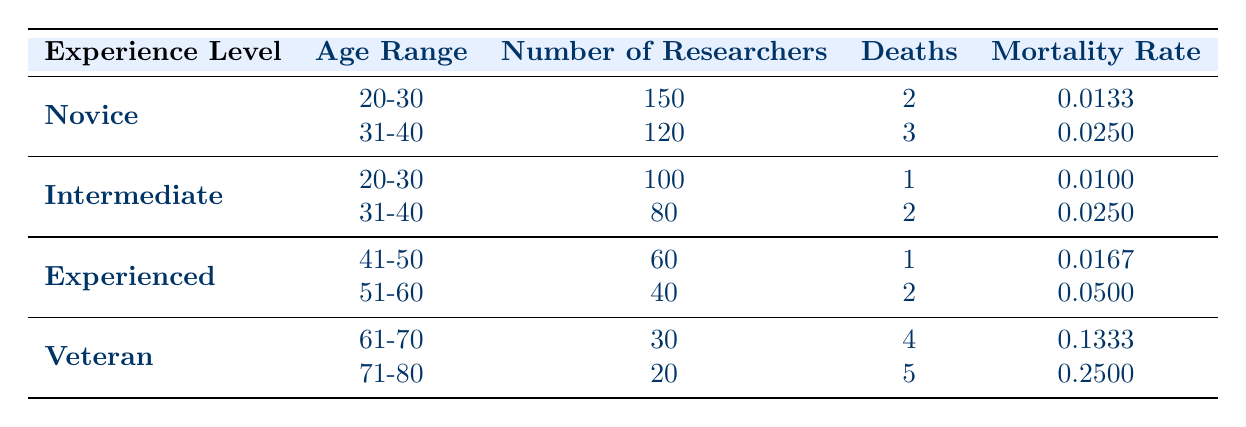What is the mortality rate for novice researchers aged 31-40? The table shows that for novice researchers in the age range of 31-40, the mortality rate is specified directly as 0.0250.
Answer: 0.0250 How many deaths occurred among experienced researchers aged 41-50? From the table, it is reported that there was 1 death among the 60 experienced researchers in the age range of 41-50.
Answer: 1 What is the total number of deaths across all experience levels? To find the total number of deaths, we add the deaths from each group: 2 (Novice 20-30) + 3 (Novice 31-40) + 1 (Intermediate 20-30) + 2 (Intermediate 31-40) + 1 (Experienced 41-50) + 2 (Experienced 51-60) + 4 (Veteran 61-70) + 5 (Veteran 71-80) = 20.
Answer: 20 Is it true that the mortality rate for veterans aged 71-80 is higher than 0.2? The table indicates that the mortality rate for veterans aged 71-80 is 0.2500, which is indeed higher than 0.2. Therefore, the statement is true.
Answer: Yes What is the average mortality rate for all intermediate researchers? To calculate the average mortality rate for intermediate researchers, we first identify the rates: 0.0100 (age 20-30) and 0.0250 (age 31-40). The average is (0.0100 + 0.0250) / 2 = 0.0175.
Answer: 0.0175 How many researchers aged 61-70 have died? According to the table, 4 deaths are reported for researchers in the age range of 61-70 who are considered veterans.
Answer: 4 Which group has the highest mortality rate? Looking through the table, the mortality rate for veterans aged 71-80 is 0.2500, which is the highest rate listed among all groups.
Answer: Veterans aged 71-80 What is the mortality rate of all novice researchers combined? To find the mortality rate for all novices, we calculate the total deaths (2 + 3 = 5) and the total number of researchers (150 + 120 = 270). The mortality rate is 5/270 ≈ 0.0185.
Answer: 0.0185 